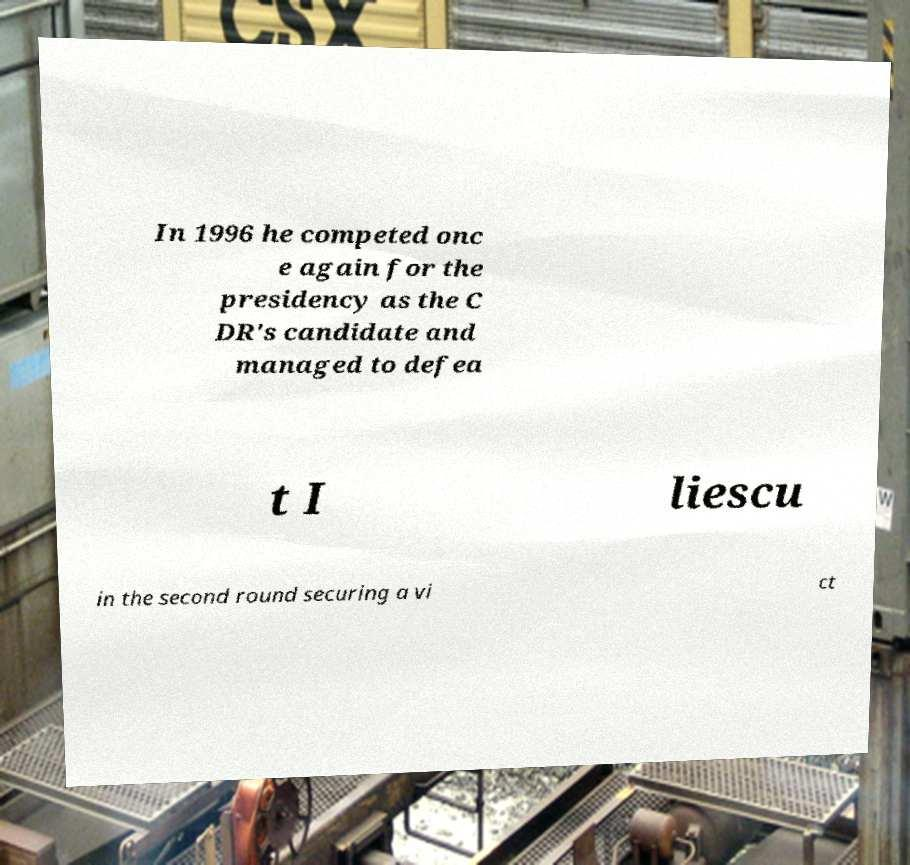I need the written content from this picture converted into text. Can you do that? In 1996 he competed onc e again for the presidency as the C DR's candidate and managed to defea t I liescu in the second round securing a vi ct 